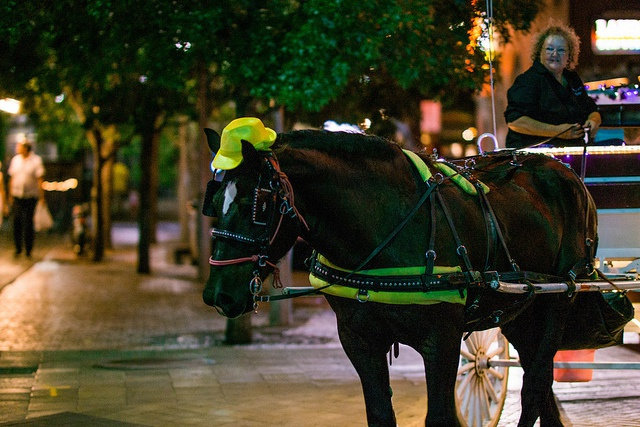Describe the objects in this image and their specific colors. I can see horse in black, maroon, and darkgreen tones, people in black, olive, maroon, and gray tones, people in black, brown, maroon, and tan tones, and people in black, olive, and maroon tones in this image. 